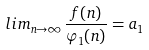Convert formula to latex. <formula><loc_0><loc_0><loc_500><loc_500>l i m _ { n \rightarrow \infty } \frac { f ( n ) } { \varphi _ { 1 } ( n ) } = a _ { 1 }</formula> 